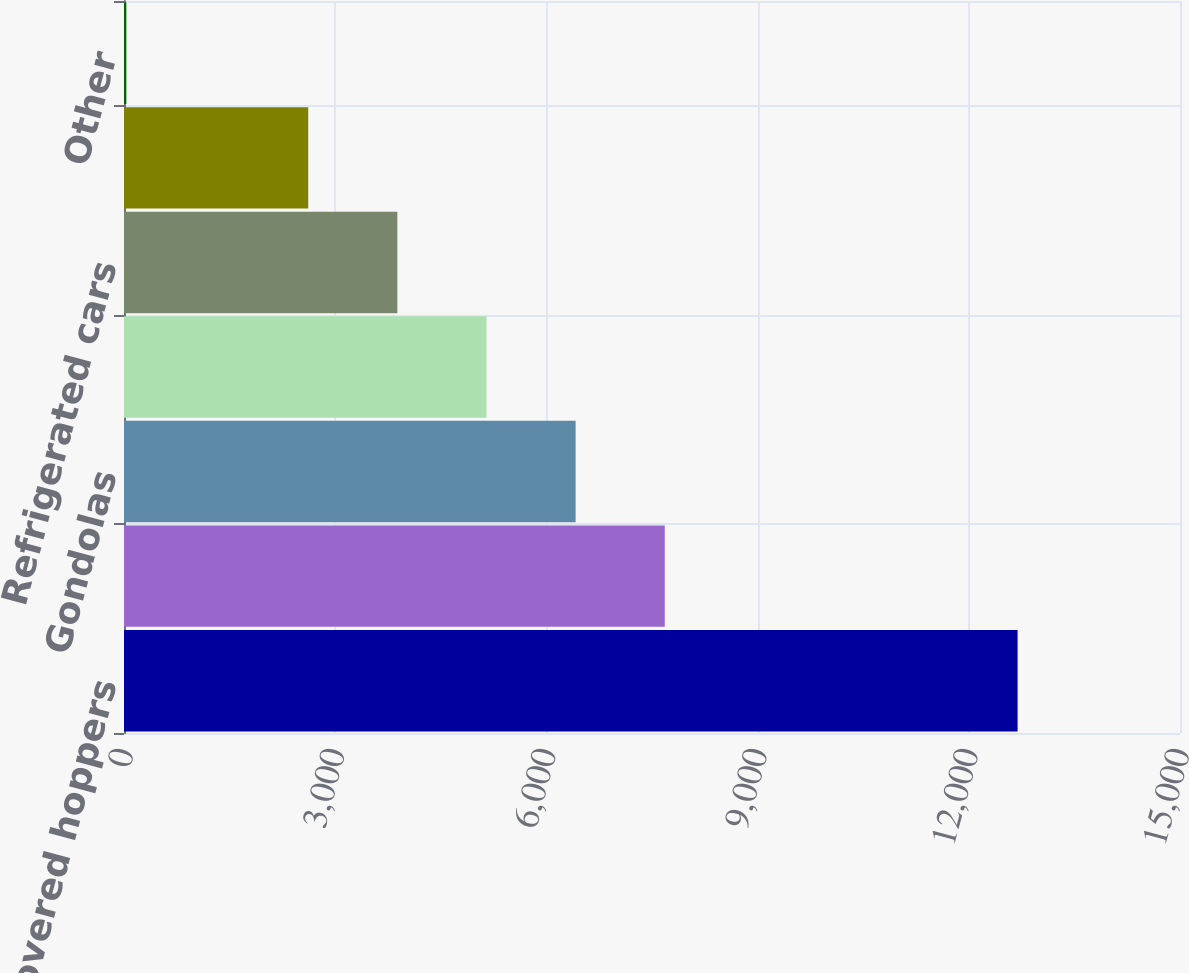Convert chart to OTSL. <chart><loc_0><loc_0><loc_500><loc_500><bar_chart><fcel>Covered hoppers<fcel>Open hoppers<fcel>Gondolas<fcel>Boxcars<fcel>Refrigerated cars<fcel>Flat cars<fcel>Other<nl><fcel>12693<fcel>7681<fcel>6415<fcel>5149<fcel>3883<fcel>2617<fcel>33<nl></chart> 